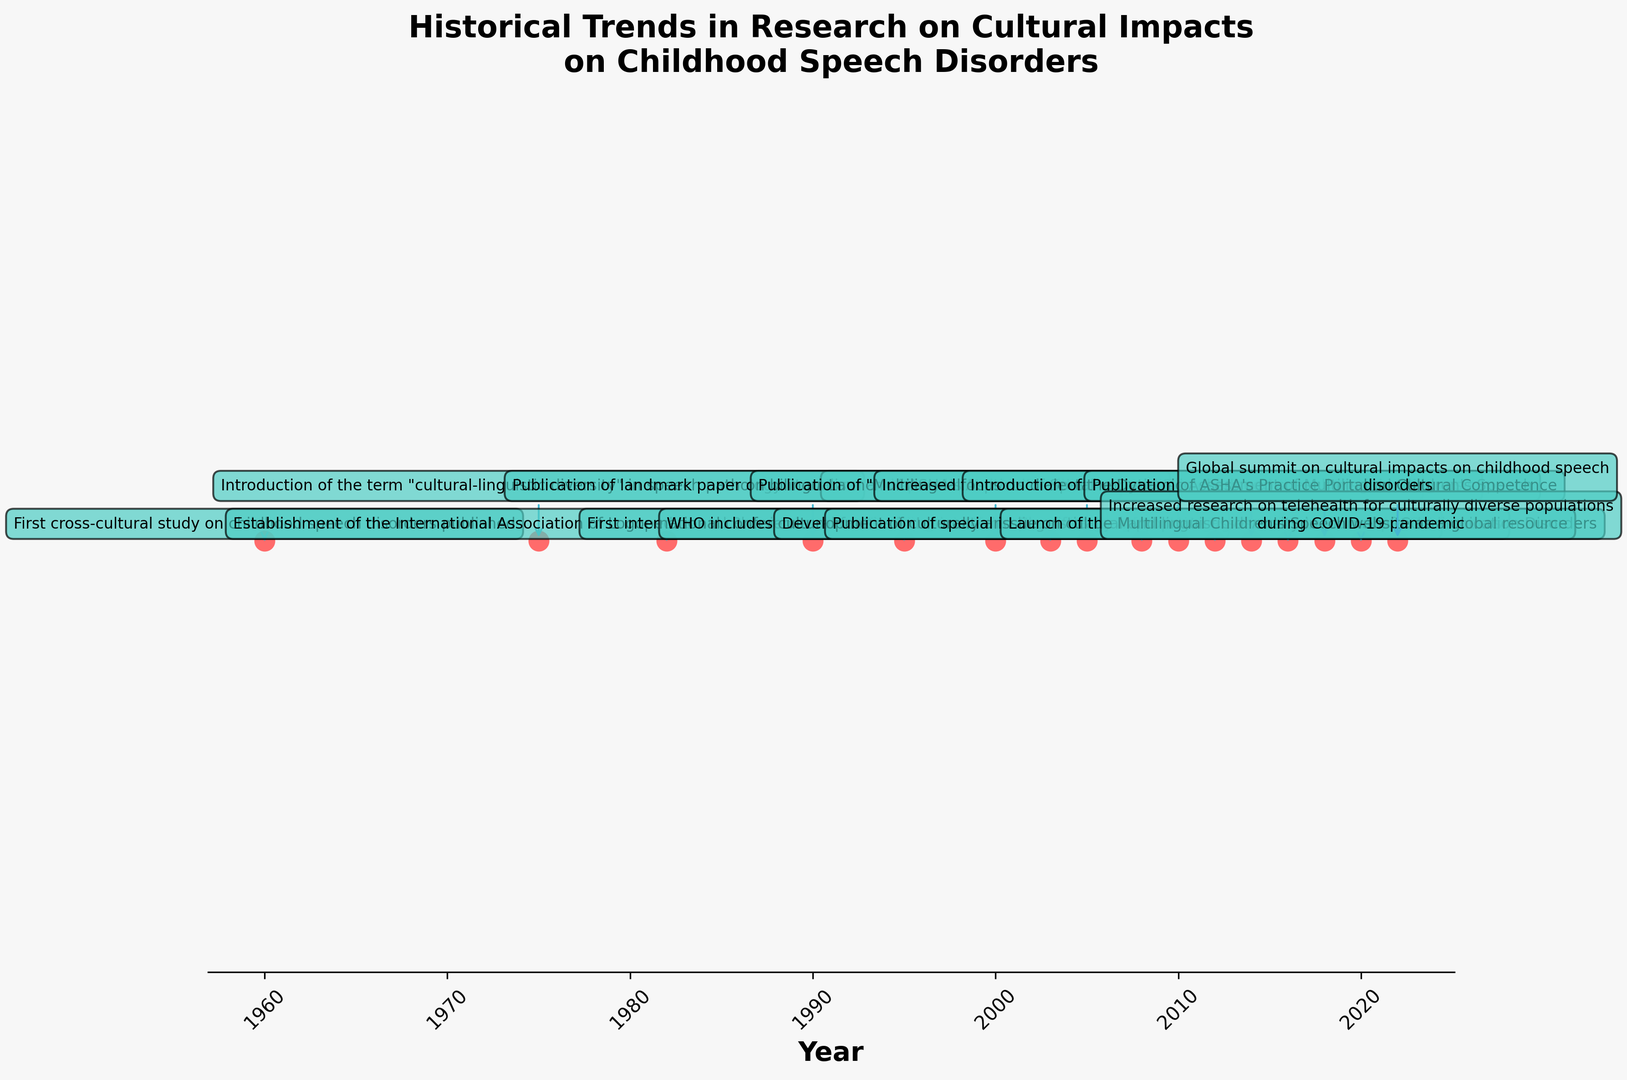Which event was introduced in 1975? The event corresponds to the year 1975 in the figure where a label points to this year. The label reads, “Introduction of the term 'cultural-linguistic diversity' in speech pathology literature.”
Answer: Introduction of the term "cultural-linguistic diversity" in speech pathology literature Which year marked the publication of the landmark paper on bilingualism and speech disorders in children? Locate the event associated with "Publication of landmark paper on bilingualism and speech disorders in children" in the figure. The corresponding year for this event is marked as 1990.
Answer: 1990 How many years passed between the first cross-cultural study on childhood speech disorders and the introduction of the Dynamic Assessment of Multilingual Children's Speech? Identify the years for both events: the first cross-cultural study in 1960 and the introduction of dynamic assessment in 2014. Subtract 1960 from 2014 to find the difference.
Answer: 54 years What is the latest event mentioned in the plot? Check the labels for the events in the figure, noting the years. The most recent year is 2022, associated with the "Global summit on cultural impacts on childhood speech disorders."
Answer: Global summit on cultural impacts on childhood speech disorders Is there any event related to WHO? If so, in which year did it occur? Search for any mention of WHO in the labels of the events. WHO is mentioned in the event "WHO includes cultural factors in International Classification of Functioning Disability and Health (ICF)" which occurred in 2003.
Answer: 2003 Which event occurred 15 years after the establishment of the International Association of Logopedics and Phoniatrics (IALP) Multilingual Affairs Committee? The establishment of the IALP Multilingual Affairs Committee happened in 1982. Adding 15 years to 1982 gives us 1997. Check the figure for an event in 1997, but there’s none; the closest one after 15 years (in 1995) is "First international conference on multicultural issues in speech-language pathology."
Answer: First international conference on multicultural issues in speech-language pathology What was the focus of research in 2010? Locate the event labeled for the year 2010 in the figure. The label reads, “Increased focus on dialectal variations in childhood speech disorder diagnosis.”
Answer: Increased focus on dialectal variations in childhood speech disorder diagnosis 